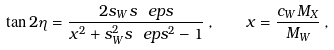<formula> <loc_0><loc_0><loc_500><loc_500>\tan { 2 \eta } = \frac { 2 s _ { W } s _ { \ } e p s } { x ^ { 2 } + s _ { W } ^ { 2 } s _ { \ } e p s ^ { 2 } - 1 } \, , \quad x = \frac { c _ { W } M _ { X } } { M _ { W } } \, ,</formula> 